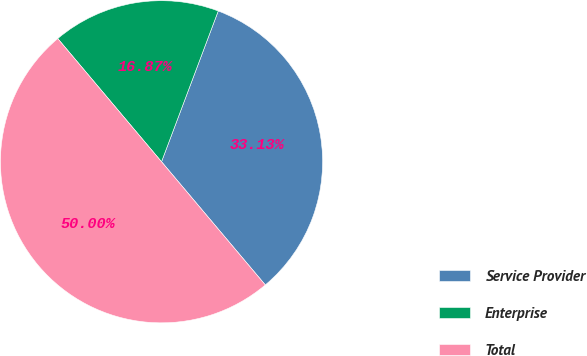<chart> <loc_0><loc_0><loc_500><loc_500><pie_chart><fcel>Service Provider<fcel>Enterprise<fcel>Total<nl><fcel>33.13%<fcel>16.87%<fcel>50.0%<nl></chart> 